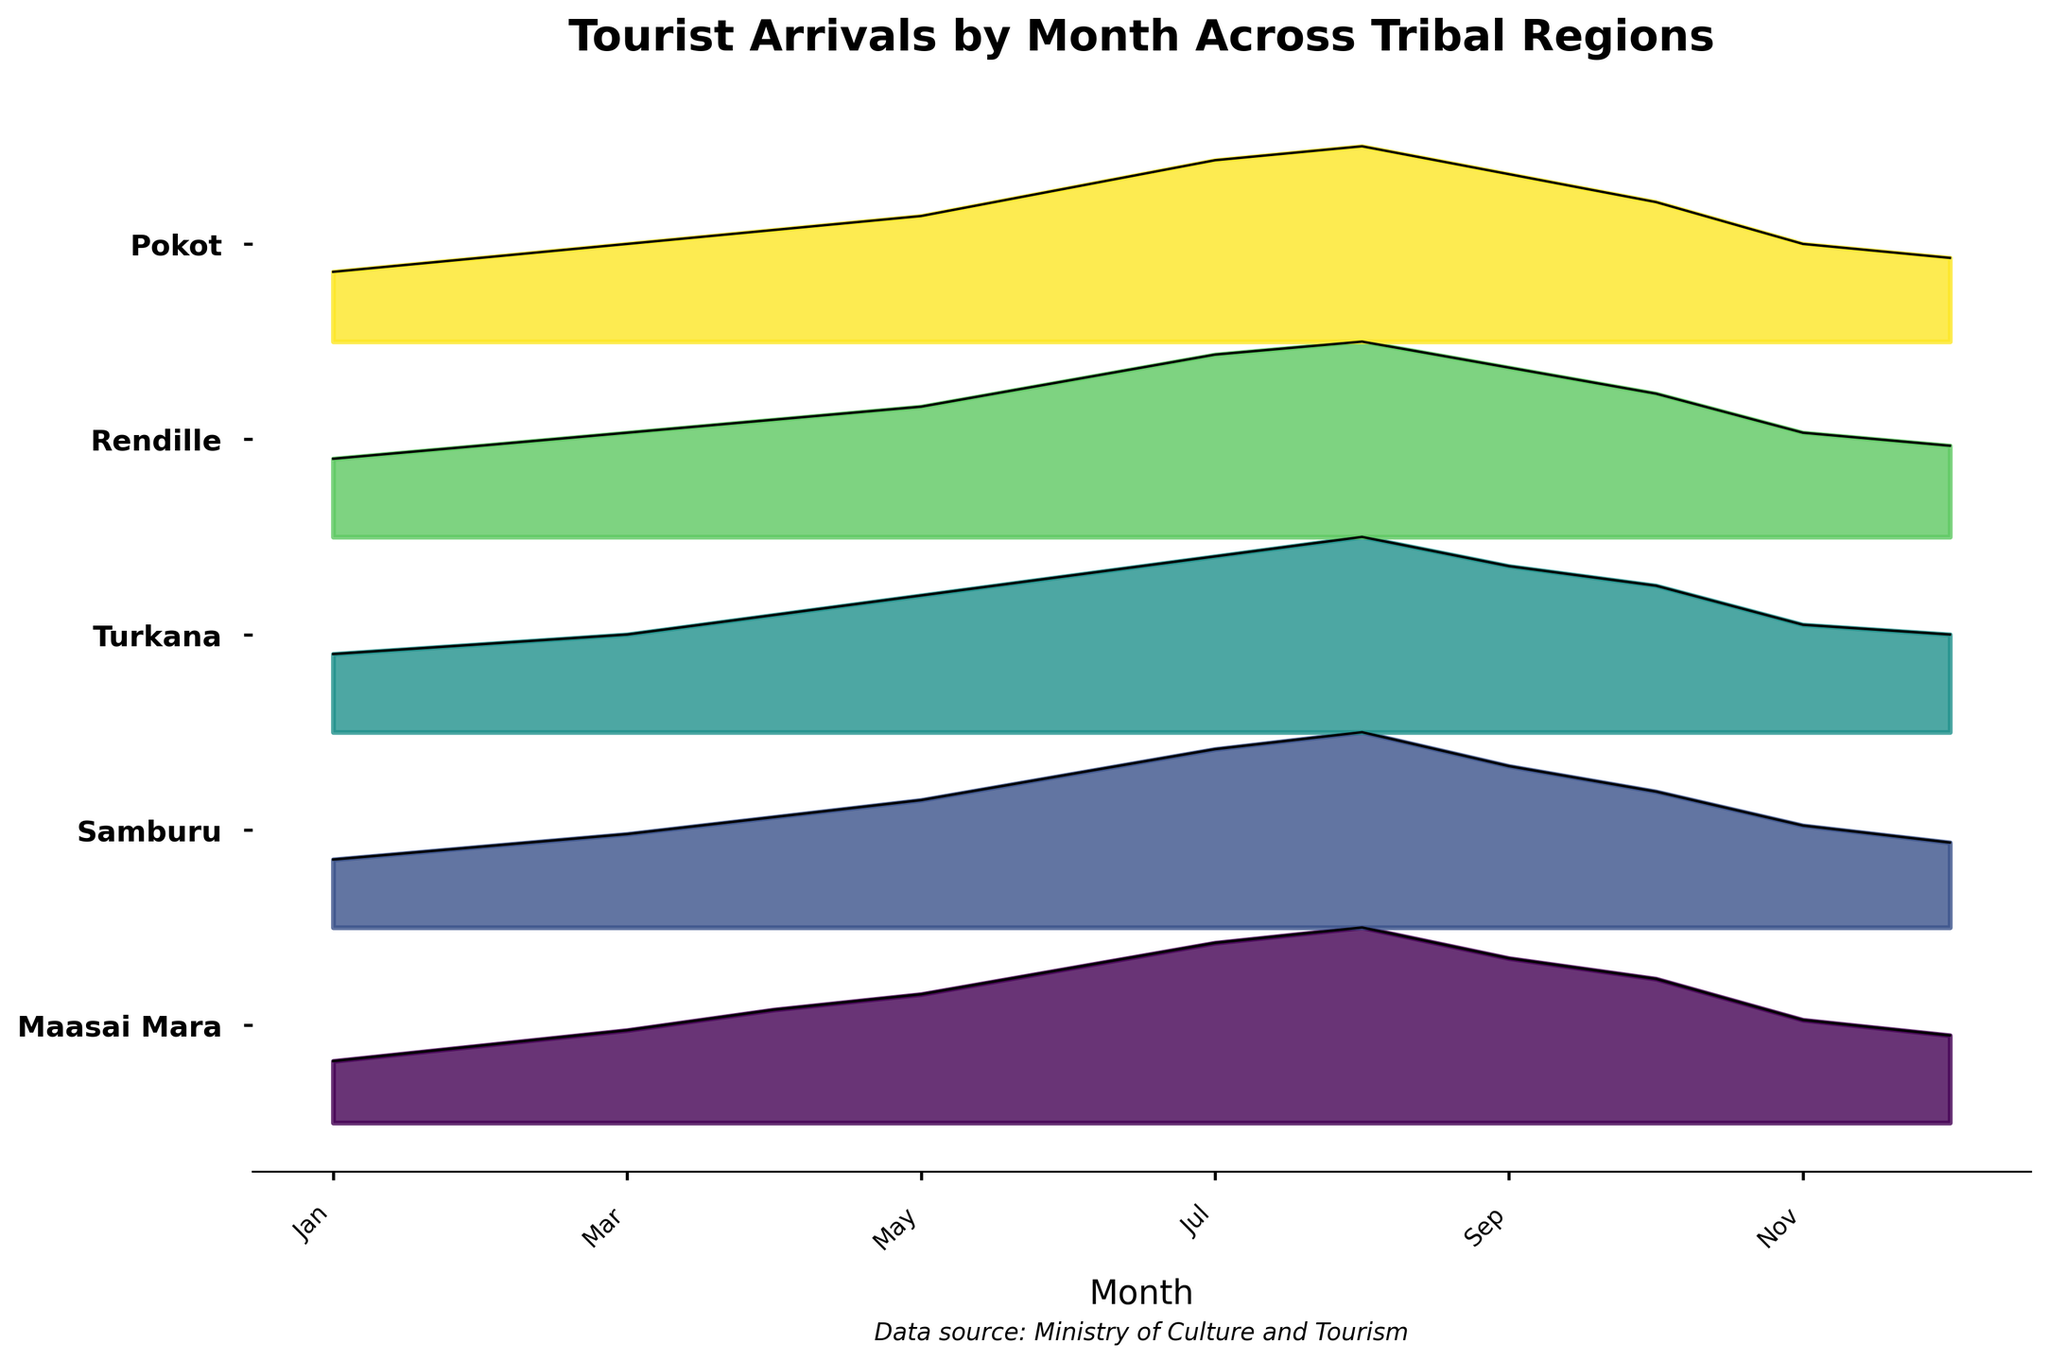Which tribal region saw the highest number of tourist arrivals in July? Locate the peak for each region and identify the tallest curve in July. The Maasai Mara region has the highest peak in this month.
Answer: Maasai Mara What is the overall trend of tourist arrivals in the Maasai Mara region throughout the year? Observe the rise and fall of the Maasai Mara curve from January to December. Tourist arrivals start increasing from January, peak in August, and then decrease towards December.
Answer: Increasing, then decreasing How many regions have their highest tourist arrivals in the month of June? Identify the peak of each region and check if June holds the highest point for any region. The Maasai Mara, Samburu, Turkana, and Rendille regions all have higher peaks after June, meaning none peak in June.
Answer: Zero Which region shows the least variability in tourist arrivals throughout the year? Compare the spread and height of each region's curve over the months. The Pokot region shows the least variation, with a generally flat line compared to other regions.
Answer: Pokot How does the number of tourists in the Samburu region in May compare to those in October? Check the heights of the Samburu ridgelines in May and October. The number is higher in May than in October.
Answer: Higher in May During which month do the Turkana region have the least number of tourist arrivals, and what is that number approximately? Look for the lowest point in the Turkana curve and identify the corresponding month and number. The minimum is in January with about 400 arrivals.
Answer: January, 400 Which two regions have the most similar trend in tourist arrivals over the year? Compare the curves of each region to find similar patterns. The Turkana and Rendille regions exhibit very similar trends in their curves.
Answer: Turkana and Rendille By how much do the number of tourist arrivals decrease in Maasai Mara from August to December? Identify the decrease by comparing the heights of the Maasai Mara's August and December peaks. August has 3800 tourists, and December has 1700 tourists, so the decrease is 3800 - 1700.
Answer: 2100 In which month do all regions experience an increase in tourist numbers compared to the previous month? Scan all five curves month-by-month to find a month where each region's line is higher than the previous month. The month of March shows an increase across all regions compared to February.
Answer: March 